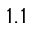Convert formula to latex. <formula><loc_0><loc_0><loc_500><loc_500>1 . 1</formula> 